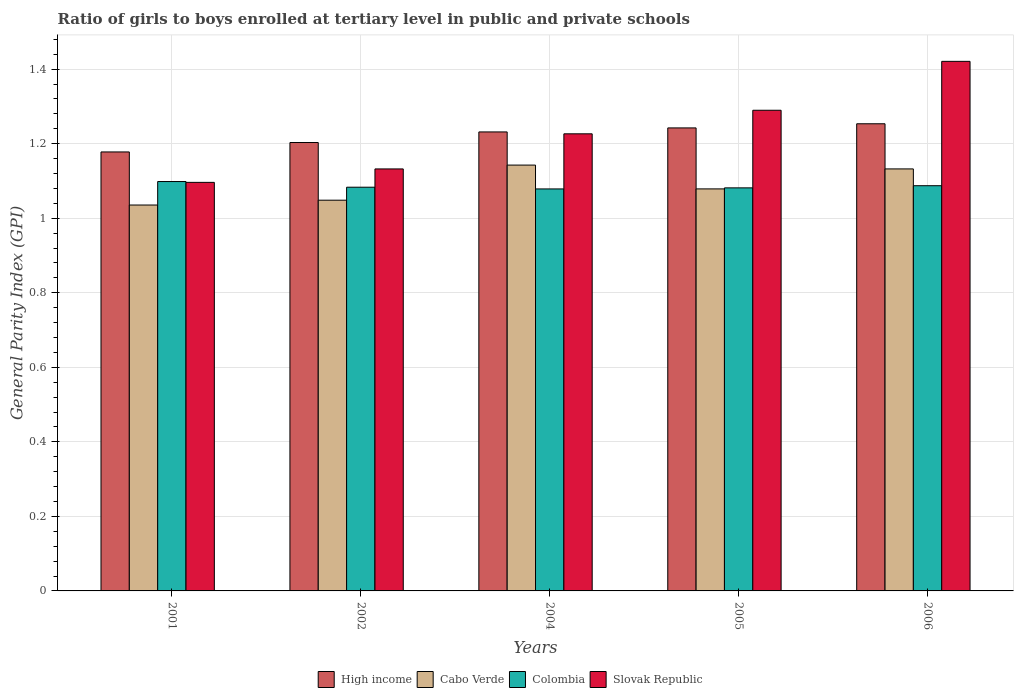How many different coloured bars are there?
Provide a succinct answer. 4. Are the number of bars per tick equal to the number of legend labels?
Keep it short and to the point. Yes. How many bars are there on the 4th tick from the right?
Keep it short and to the point. 4. In how many cases, is the number of bars for a given year not equal to the number of legend labels?
Your response must be concise. 0. What is the general parity index in Slovak Republic in 2002?
Your answer should be compact. 1.13. Across all years, what is the maximum general parity index in Slovak Republic?
Offer a very short reply. 1.42. Across all years, what is the minimum general parity index in Colombia?
Your answer should be compact. 1.08. In which year was the general parity index in Colombia maximum?
Your answer should be compact. 2001. In which year was the general parity index in High income minimum?
Give a very brief answer. 2001. What is the total general parity index in High income in the graph?
Your answer should be compact. 6.11. What is the difference between the general parity index in High income in 2005 and that in 2006?
Your response must be concise. -0.01. What is the difference between the general parity index in Slovak Republic in 2005 and the general parity index in Cabo Verde in 2002?
Your answer should be very brief. 0.24. What is the average general parity index in Cabo Verde per year?
Keep it short and to the point. 1.09. In the year 2001, what is the difference between the general parity index in High income and general parity index in Cabo Verde?
Offer a very short reply. 0.14. What is the ratio of the general parity index in High income in 2001 to that in 2005?
Provide a succinct answer. 0.95. Is the general parity index in Colombia in 2004 less than that in 2006?
Your answer should be very brief. Yes. Is the difference between the general parity index in High income in 2001 and 2005 greater than the difference between the general parity index in Cabo Verde in 2001 and 2005?
Offer a terse response. No. What is the difference between the highest and the second highest general parity index in High income?
Your answer should be compact. 0.01. What is the difference between the highest and the lowest general parity index in Colombia?
Keep it short and to the point. 0.02. Is it the case that in every year, the sum of the general parity index in High income and general parity index in Cabo Verde is greater than the sum of general parity index in Slovak Republic and general parity index in Colombia?
Make the answer very short. Yes. What does the 2nd bar from the left in 2004 represents?
Provide a succinct answer. Cabo Verde. Is it the case that in every year, the sum of the general parity index in Slovak Republic and general parity index in Cabo Verde is greater than the general parity index in High income?
Offer a terse response. Yes. What is the difference between two consecutive major ticks on the Y-axis?
Make the answer very short. 0.2. Does the graph contain grids?
Provide a short and direct response. Yes. How many legend labels are there?
Your response must be concise. 4. What is the title of the graph?
Provide a succinct answer. Ratio of girls to boys enrolled at tertiary level in public and private schools. Does "Seychelles" appear as one of the legend labels in the graph?
Give a very brief answer. No. What is the label or title of the Y-axis?
Ensure brevity in your answer.  General Parity Index (GPI). What is the General Parity Index (GPI) in High income in 2001?
Give a very brief answer. 1.18. What is the General Parity Index (GPI) in Cabo Verde in 2001?
Offer a terse response. 1.04. What is the General Parity Index (GPI) in Colombia in 2001?
Provide a succinct answer. 1.1. What is the General Parity Index (GPI) of Slovak Republic in 2001?
Your answer should be very brief. 1.1. What is the General Parity Index (GPI) in High income in 2002?
Keep it short and to the point. 1.2. What is the General Parity Index (GPI) in Cabo Verde in 2002?
Provide a short and direct response. 1.05. What is the General Parity Index (GPI) of Colombia in 2002?
Provide a succinct answer. 1.08. What is the General Parity Index (GPI) in Slovak Republic in 2002?
Your answer should be very brief. 1.13. What is the General Parity Index (GPI) in High income in 2004?
Offer a terse response. 1.23. What is the General Parity Index (GPI) of Cabo Verde in 2004?
Your response must be concise. 1.14. What is the General Parity Index (GPI) of Colombia in 2004?
Your answer should be very brief. 1.08. What is the General Parity Index (GPI) of Slovak Republic in 2004?
Offer a terse response. 1.23. What is the General Parity Index (GPI) in High income in 2005?
Make the answer very short. 1.24. What is the General Parity Index (GPI) in Cabo Verde in 2005?
Your answer should be very brief. 1.08. What is the General Parity Index (GPI) of Colombia in 2005?
Ensure brevity in your answer.  1.08. What is the General Parity Index (GPI) of Slovak Republic in 2005?
Offer a terse response. 1.29. What is the General Parity Index (GPI) in High income in 2006?
Give a very brief answer. 1.25. What is the General Parity Index (GPI) in Cabo Verde in 2006?
Your answer should be compact. 1.13. What is the General Parity Index (GPI) of Colombia in 2006?
Ensure brevity in your answer.  1.09. What is the General Parity Index (GPI) in Slovak Republic in 2006?
Keep it short and to the point. 1.42. Across all years, what is the maximum General Parity Index (GPI) in High income?
Provide a succinct answer. 1.25. Across all years, what is the maximum General Parity Index (GPI) in Cabo Verde?
Provide a short and direct response. 1.14. Across all years, what is the maximum General Parity Index (GPI) of Colombia?
Ensure brevity in your answer.  1.1. Across all years, what is the maximum General Parity Index (GPI) in Slovak Republic?
Provide a succinct answer. 1.42. Across all years, what is the minimum General Parity Index (GPI) of High income?
Give a very brief answer. 1.18. Across all years, what is the minimum General Parity Index (GPI) in Cabo Verde?
Offer a very short reply. 1.04. Across all years, what is the minimum General Parity Index (GPI) in Colombia?
Offer a terse response. 1.08. Across all years, what is the minimum General Parity Index (GPI) in Slovak Republic?
Keep it short and to the point. 1.1. What is the total General Parity Index (GPI) of High income in the graph?
Your answer should be compact. 6.11. What is the total General Parity Index (GPI) in Cabo Verde in the graph?
Give a very brief answer. 5.44. What is the total General Parity Index (GPI) in Colombia in the graph?
Provide a succinct answer. 5.43. What is the total General Parity Index (GPI) of Slovak Republic in the graph?
Ensure brevity in your answer.  6.16. What is the difference between the General Parity Index (GPI) in High income in 2001 and that in 2002?
Your answer should be very brief. -0.03. What is the difference between the General Parity Index (GPI) of Cabo Verde in 2001 and that in 2002?
Your response must be concise. -0.01. What is the difference between the General Parity Index (GPI) of Colombia in 2001 and that in 2002?
Give a very brief answer. 0.02. What is the difference between the General Parity Index (GPI) in Slovak Republic in 2001 and that in 2002?
Your answer should be very brief. -0.04. What is the difference between the General Parity Index (GPI) of High income in 2001 and that in 2004?
Make the answer very short. -0.05. What is the difference between the General Parity Index (GPI) of Cabo Verde in 2001 and that in 2004?
Provide a short and direct response. -0.11. What is the difference between the General Parity Index (GPI) in Colombia in 2001 and that in 2004?
Ensure brevity in your answer.  0.02. What is the difference between the General Parity Index (GPI) in Slovak Republic in 2001 and that in 2004?
Provide a succinct answer. -0.13. What is the difference between the General Parity Index (GPI) of High income in 2001 and that in 2005?
Offer a very short reply. -0.06. What is the difference between the General Parity Index (GPI) in Cabo Verde in 2001 and that in 2005?
Provide a succinct answer. -0.04. What is the difference between the General Parity Index (GPI) in Colombia in 2001 and that in 2005?
Your response must be concise. 0.02. What is the difference between the General Parity Index (GPI) of Slovak Republic in 2001 and that in 2005?
Provide a short and direct response. -0.19. What is the difference between the General Parity Index (GPI) in High income in 2001 and that in 2006?
Provide a short and direct response. -0.08. What is the difference between the General Parity Index (GPI) of Cabo Verde in 2001 and that in 2006?
Your response must be concise. -0.1. What is the difference between the General Parity Index (GPI) of Colombia in 2001 and that in 2006?
Provide a succinct answer. 0.01. What is the difference between the General Parity Index (GPI) in Slovak Republic in 2001 and that in 2006?
Give a very brief answer. -0.32. What is the difference between the General Parity Index (GPI) in High income in 2002 and that in 2004?
Give a very brief answer. -0.03. What is the difference between the General Parity Index (GPI) in Cabo Verde in 2002 and that in 2004?
Your answer should be very brief. -0.09. What is the difference between the General Parity Index (GPI) of Colombia in 2002 and that in 2004?
Offer a terse response. 0. What is the difference between the General Parity Index (GPI) in Slovak Republic in 2002 and that in 2004?
Provide a short and direct response. -0.09. What is the difference between the General Parity Index (GPI) in High income in 2002 and that in 2005?
Provide a succinct answer. -0.04. What is the difference between the General Parity Index (GPI) in Cabo Verde in 2002 and that in 2005?
Your response must be concise. -0.03. What is the difference between the General Parity Index (GPI) of Colombia in 2002 and that in 2005?
Your response must be concise. 0. What is the difference between the General Parity Index (GPI) in Slovak Republic in 2002 and that in 2005?
Provide a short and direct response. -0.16. What is the difference between the General Parity Index (GPI) of High income in 2002 and that in 2006?
Your answer should be very brief. -0.05. What is the difference between the General Parity Index (GPI) of Cabo Verde in 2002 and that in 2006?
Provide a short and direct response. -0.08. What is the difference between the General Parity Index (GPI) in Colombia in 2002 and that in 2006?
Ensure brevity in your answer.  -0. What is the difference between the General Parity Index (GPI) of Slovak Republic in 2002 and that in 2006?
Provide a succinct answer. -0.29. What is the difference between the General Parity Index (GPI) in High income in 2004 and that in 2005?
Offer a terse response. -0.01. What is the difference between the General Parity Index (GPI) of Cabo Verde in 2004 and that in 2005?
Provide a short and direct response. 0.06. What is the difference between the General Parity Index (GPI) of Colombia in 2004 and that in 2005?
Ensure brevity in your answer.  -0. What is the difference between the General Parity Index (GPI) in Slovak Republic in 2004 and that in 2005?
Offer a very short reply. -0.06. What is the difference between the General Parity Index (GPI) of High income in 2004 and that in 2006?
Your answer should be very brief. -0.02. What is the difference between the General Parity Index (GPI) in Cabo Verde in 2004 and that in 2006?
Your answer should be compact. 0.01. What is the difference between the General Parity Index (GPI) of Colombia in 2004 and that in 2006?
Provide a succinct answer. -0.01. What is the difference between the General Parity Index (GPI) in Slovak Republic in 2004 and that in 2006?
Make the answer very short. -0.19. What is the difference between the General Parity Index (GPI) in High income in 2005 and that in 2006?
Provide a short and direct response. -0.01. What is the difference between the General Parity Index (GPI) in Cabo Verde in 2005 and that in 2006?
Offer a very short reply. -0.05. What is the difference between the General Parity Index (GPI) in Colombia in 2005 and that in 2006?
Ensure brevity in your answer.  -0.01. What is the difference between the General Parity Index (GPI) in Slovak Republic in 2005 and that in 2006?
Provide a short and direct response. -0.13. What is the difference between the General Parity Index (GPI) in High income in 2001 and the General Parity Index (GPI) in Cabo Verde in 2002?
Your answer should be compact. 0.13. What is the difference between the General Parity Index (GPI) in High income in 2001 and the General Parity Index (GPI) in Colombia in 2002?
Give a very brief answer. 0.09. What is the difference between the General Parity Index (GPI) in High income in 2001 and the General Parity Index (GPI) in Slovak Republic in 2002?
Your answer should be compact. 0.05. What is the difference between the General Parity Index (GPI) in Cabo Verde in 2001 and the General Parity Index (GPI) in Colombia in 2002?
Offer a terse response. -0.05. What is the difference between the General Parity Index (GPI) of Cabo Verde in 2001 and the General Parity Index (GPI) of Slovak Republic in 2002?
Your answer should be compact. -0.1. What is the difference between the General Parity Index (GPI) of Colombia in 2001 and the General Parity Index (GPI) of Slovak Republic in 2002?
Provide a short and direct response. -0.03. What is the difference between the General Parity Index (GPI) of High income in 2001 and the General Parity Index (GPI) of Cabo Verde in 2004?
Make the answer very short. 0.04. What is the difference between the General Parity Index (GPI) in High income in 2001 and the General Parity Index (GPI) in Colombia in 2004?
Your answer should be very brief. 0.1. What is the difference between the General Parity Index (GPI) of High income in 2001 and the General Parity Index (GPI) of Slovak Republic in 2004?
Your response must be concise. -0.05. What is the difference between the General Parity Index (GPI) in Cabo Verde in 2001 and the General Parity Index (GPI) in Colombia in 2004?
Make the answer very short. -0.04. What is the difference between the General Parity Index (GPI) of Cabo Verde in 2001 and the General Parity Index (GPI) of Slovak Republic in 2004?
Offer a very short reply. -0.19. What is the difference between the General Parity Index (GPI) in Colombia in 2001 and the General Parity Index (GPI) in Slovak Republic in 2004?
Your answer should be compact. -0.13. What is the difference between the General Parity Index (GPI) in High income in 2001 and the General Parity Index (GPI) in Cabo Verde in 2005?
Provide a short and direct response. 0.1. What is the difference between the General Parity Index (GPI) in High income in 2001 and the General Parity Index (GPI) in Colombia in 2005?
Give a very brief answer. 0.1. What is the difference between the General Parity Index (GPI) in High income in 2001 and the General Parity Index (GPI) in Slovak Republic in 2005?
Your answer should be compact. -0.11. What is the difference between the General Parity Index (GPI) of Cabo Verde in 2001 and the General Parity Index (GPI) of Colombia in 2005?
Offer a very short reply. -0.05. What is the difference between the General Parity Index (GPI) in Cabo Verde in 2001 and the General Parity Index (GPI) in Slovak Republic in 2005?
Keep it short and to the point. -0.25. What is the difference between the General Parity Index (GPI) in Colombia in 2001 and the General Parity Index (GPI) in Slovak Republic in 2005?
Offer a terse response. -0.19. What is the difference between the General Parity Index (GPI) in High income in 2001 and the General Parity Index (GPI) in Cabo Verde in 2006?
Your answer should be compact. 0.05. What is the difference between the General Parity Index (GPI) of High income in 2001 and the General Parity Index (GPI) of Colombia in 2006?
Ensure brevity in your answer.  0.09. What is the difference between the General Parity Index (GPI) in High income in 2001 and the General Parity Index (GPI) in Slovak Republic in 2006?
Your answer should be very brief. -0.24. What is the difference between the General Parity Index (GPI) in Cabo Verde in 2001 and the General Parity Index (GPI) in Colombia in 2006?
Your answer should be compact. -0.05. What is the difference between the General Parity Index (GPI) in Cabo Verde in 2001 and the General Parity Index (GPI) in Slovak Republic in 2006?
Your response must be concise. -0.39. What is the difference between the General Parity Index (GPI) in Colombia in 2001 and the General Parity Index (GPI) in Slovak Republic in 2006?
Keep it short and to the point. -0.32. What is the difference between the General Parity Index (GPI) of High income in 2002 and the General Parity Index (GPI) of Cabo Verde in 2004?
Provide a succinct answer. 0.06. What is the difference between the General Parity Index (GPI) of High income in 2002 and the General Parity Index (GPI) of Colombia in 2004?
Your response must be concise. 0.12. What is the difference between the General Parity Index (GPI) in High income in 2002 and the General Parity Index (GPI) in Slovak Republic in 2004?
Provide a succinct answer. -0.02. What is the difference between the General Parity Index (GPI) of Cabo Verde in 2002 and the General Parity Index (GPI) of Colombia in 2004?
Offer a very short reply. -0.03. What is the difference between the General Parity Index (GPI) of Cabo Verde in 2002 and the General Parity Index (GPI) of Slovak Republic in 2004?
Keep it short and to the point. -0.18. What is the difference between the General Parity Index (GPI) of Colombia in 2002 and the General Parity Index (GPI) of Slovak Republic in 2004?
Keep it short and to the point. -0.14. What is the difference between the General Parity Index (GPI) in High income in 2002 and the General Parity Index (GPI) in Cabo Verde in 2005?
Your answer should be very brief. 0.12. What is the difference between the General Parity Index (GPI) of High income in 2002 and the General Parity Index (GPI) of Colombia in 2005?
Give a very brief answer. 0.12. What is the difference between the General Parity Index (GPI) of High income in 2002 and the General Parity Index (GPI) of Slovak Republic in 2005?
Provide a succinct answer. -0.09. What is the difference between the General Parity Index (GPI) in Cabo Verde in 2002 and the General Parity Index (GPI) in Colombia in 2005?
Provide a succinct answer. -0.03. What is the difference between the General Parity Index (GPI) in Cabo Verde in 2002 and the General Parity Index (GPI) in Slovak Republic in 2005?
Your response must be concise. -0.24. What is the difference between the General Parity Index (GPI) of Colombia in 2002 and the General Parity Index (GPI) of Slovak Republic in 2005?
Your answer should be very brief. -0.21. What is the difference between the General Parity Index (GPI) in High income in 2002 and the General Parity Index (GPI) in Cabo Verde in 2006?
Your answer should be compact. 0.07. What is the difference between the General Parity Index (GPI) in High income in 2002 and the General Parity Index (GPI) in Colombia in 2006?
Give a very brief answer. 0.12. What is the difference between the General Parity Index (GPI) in High income in 2002 and the General Parity Index (GPI) in Slovak Republic in 2006?
Provide a succinct answer. -0.22. What is the difference between the General Parity Index (GPI) in Cabo Verde in 2002 and the General Parity Index (GPI) in Colombia in 2006?
Make the answer very short. -0.04. What is the difference between the General Parity Index (GPI) in Cabo Verde in 2002 and the General Parity Index (GPI) in Slovak Republic in 2006?
Keep it short and to the point. -0.37. What is the difference between the General Parity Index (GPI) of Colombia in 2002 and the General Parity Index (GPI) of Slovak Republic in 2006?
Give a very brief answer. -0.34. What is the difference between the General Parity Index (GPI) of High income in 2004 and the General Parity Index (GPI) of Cabo Verde in 2005?
Ensure brevity in your answer.  0.15. What is the difference between the General Parity Index (GPI) of High income in 2004 and the General Parity Index (GPI) of Colombia in 2005?
Give a very brief answer. 0.15. What is the difference between the General Parity Index (GPI) in High income in 2004 and the General Parity Index (GPI) in Slovak Republic in 2005?
Make the answer very short. -0.06. What is the difference between the General Parity Index (GPI) in Cabo Verde in 2004 and the General Parity Index (GPI) in Colombia in 2005?
Ensure brevity in your answer.  0.06. What is the difference between the General Parity Index (GPI) of Cabo Verde in 2004 and the General Parity Index (GPI) of Slovak Republic in 2005?
Ensure brevity in your answer.  -0.15. What is the difference between the General Parity Index (GPI) in Colombia in 2004 and the General Parity Index (GPI) in Slovak Republic in 2005?
Give a very brief answer. -0.21. What is the difference between the General Parity Index (GPI) of High income in 2004 and the General Parity Index (GPI) of Cabo Verde in 2006?
Your answer should be very brief. 0.1. What is the difference between the General Parity Index (GPI) in High income in 2004 and the General Parity Index (GPI) in Colombia in 2006?
Offer a terse response. 0.14. What is the difference between the General Parity Index (GPI) in High income in 2004 and the General Parity Index (GPI) in Slovak Republic in 2006?
Keep it short and to the point. -0.19. What is the difference between the General Parity Index (GPI) of Cabo Verde in 2004 and the General Parity Index (GPI) of Colombia in 2006?
Provide a short and direct response. 0.06. What is the difference between the General Parity Index (GPI) in Cabo Verde in 2004 and the General Parity Index (GPI) in Slovak Republic in 2006?
Your response must be concise. -0.28. What is the difference between the General Parity Index (GPI) in Colombia in 2004 and the General Parity Index (GPI) in Slovak Republic in 2006?
Your answer should be compact. -0.34. What is the difference between the General Parity Index (GPI) in High income in 2005 and the General Parity Index (GPI) in Cabo Verde in 2006?
Your response must be concise. 0.11. What is the difference between the General Parity Index (GPI) of High income in 2005 and the General Parity Index (GPI) of Colombia in 2006?
Your response must be concise. 0.16. What is the difference between the General Parity Index (GPI) in High income in 2005 and the General Parity Index (GPI) in Slovak Republic in 2006?
Your response must be concise. -0.18. What is the difference between the General Parity Index (GPI) of Cabo Verde in 2005 and the General Parity Index (GPI) of Colombia in 2006?
Keep it short and to the point. -0.01. What is the difference between the General Parity Index (GPI) in Cabo Verde in 2005 and the General Parity Index (GPI) in Slovak Republic in 2006?
Your response must be concise. -0.34. What is the difference between the General Parity Index (GPI) in Colombia in 2005 and the General Parity Index (GPI) in Slovak Republic in 2006?
Ensure brevity in your answer.  -0.34. What is the average General Parity Index (GPI) of High income per year?
Provide a succinct answer. 1.22. What is the average General Parity Index (GPI) in Cabo Verde per year?
Provide a succinct answer. 1.09. What is the average General Parity Index (GPI) of Colombia per year?
Your answer should be very brief. 1.09. What is the average General Parity Index (GPI) of Slovak Republic per year?
Provide a short and direct response. 1.23. In the year 2001, what is the difference between the General Parity Index (GPI) in High income and General Parity Index (GPI) in Cabo Verde?
Offer a terse response. 0.14. In the year 2001, what is the difference between the General Parity Index (GPI) of High income and General Parity Index (GPI) of Colombia?
Your answer should be very brief. 0.08. In the year 2001, what is the difference between the General Parity Index (GPI) in High income and General Parity Index (GPI) in Slovak Republic?
Offer a very short reply. 0.08. In the year 2001, what is the difference between the General Parity Index (GPI) in Cabo Verde and General Parity Index (GPI) in Colombia?
Make the answer very short. -0.06. In the year 2001, what is the difference between the General Parity Index (GPI) of Cabo Verde and General Parity Index (GPI) of Slovak Republic?
Your answer should be compact. -0.06. In the year 2001, what is the difference between the General Parity Index (GPI) of Colombia and General Parity Index (GPI) of Slovak Republic?
Offer a terse response. 0. In the year 2002, what is the difference between the General Parity Index (GPI) of High income and General Parity Index (GPI) of Cabo Verde?
Ensure brevity in your answer.  0.15. In the year 2002, what is the difference between the General Parity Index (GPI) of High income and General Parity Index (GPI) of Colombia?
Keep it short and to the point. 0.12. In the year 2002, what is the difference between the General Parity Index (GPI) of High income and General Parity Index (GPI) of Slovak Republic?
Keep it short and to the point. 0.07. In the year 2002, what is the difference between the General Parity Index (GPI) in Cabo Verde and General Parity Index (GPI) in Colombia?
Your response must be concise. -0.03. In the year 2002, what is the difference between the General Parity Index (GPI) of Cabo Verde and General Parity Index (GPI) of Slovak Republic?
Ensure brevity in your answer.  -0.08. In the year 2002, what is the difference between the General Parity Index (GPI) of Colombia and General Parity Index (GPI) of Slovak Republic?
Provide a succinct answer. -0.05. In the year 2004, what is the difference between the General Parity Index (GPI) in High income and General Parity Index (GPI) in Cabo Verde?
Give a very brief answer. 0.09. In the year 2004, what is the difference between the General Parity Index (GPI) in High income and General Parity Index (GPI) in Colombia?
Offer a very short reply. 0.15. In the year 2004, what is the difference between the General Parity Index (GPI) of High income and General Parity Index (GPI) of Slovak Republic?
Give a very brief answer. 0.01. In the year 2004, what is the difference between the General Parity Index (GPI) in Cabo Verde and General Parity Index (GPI) in Colombia?
Ensure brevity in your answer.  0.06. In the year 2004, what is the difference between the General Parity Index (GPI) in Cabo Verde and General Parity Index (GPI) in Slovak Republic?
Provide a succinct answer. -0.08. In the year 2004, what is the difference between the General Parity Index (GPI) of Colombia and General Parity Index (GPI) of Slovak Republic?
Your answer should be compact. -0.15. In the year 2005, what is the difference between the General Parity Index (GPI) of High income and General Parity Index (GPI) of Cabo Verde?
Your answer should be very brief. 0.16. In the year 2005, what is the difference between the General Parity Index (GPI) in High income and General Parity Index (GPI) in Colombia?
Give a very brief answer. 0.16. In the year 2005, what is the difference between the General Parity Index (GPI) in High income and General Parity Index (GPI) in Slovak Republic?
Provide a succinct answer. -0.05. In the year 2005, what is the difference between the General Parity Index (GPI) of Cabo Verde and General Parity Index (GPI) of Colombia?
Your answer should be very brief. -0. In the year 2005, what is the difference between the General Parity Index (GPI) in Cabo Verde and General Parity Index (GPI) in Slovak Republic?
Make the answer very short. -0.21. In the year 2005, what is the difference between the General Parity Index (GPI) in Colombia and General Parity Index (GPI) in Slovak Republic?
Make the answer very short. -0.21. In the year 2006, what is the difference between the General Parity Index (GPI) of High income and General Parity Index (GPI) of Cabo Verde?
Make the answer very short. 0.12. In the year 2006, what is the difference between the General Parity Index (GPI) of High income and General Parity Index (GPI) of Colombia?
Provide a short and direct response. 0.17. In the year 2006, what is the difference between the General Parity Index (GPI) in High income and General Parity Index (GPI) in Slovak Republic?
Ensure brevity in your answer.  -0.17. In the year 2006, what is the difference between the General Parity Index (GPI) of Cabo Verde and General Parity Index (GPI) of Colombia?
Keep it short and to the point. 0.05. In the year 2006, what is the difference between the General Parity Index (GPI) in Cabo Verde and General Parity Index (GPI) in Slovak Republic?
Your response must be concise. -0.29. In the year 2006, what is the difference between the General Parity Index (GPI) in Colombia and General Parity Index (GPI) in Slovak Republic?
Your response must be concise. -0.33. What is the ratio of the General Parity Index (GPI) of Cabo Verde in 2001 to that in 2002?
Make the answer very short. 0.99. What is the ratio of the General Parity Index (GPI) of Colombia in 2001 to that in 2002?
Your answer should be compact. 1.01. What is the ratio of the General Parity Index (GPI) in Slovak Republic in 2001 to that in 2002?
Make the answer very short. 0.97. What is the ratio of the General Parity Index (GPI) in High income in 2001 to that in 2004?
Provide a short and direct response. 0.96. What is the ratio of the General Parity Index (GPI) in Cabo Verde in 2001 to that in 2004?
Offer a terse response. 0.91. What is the ratio of the General Parity Index (GPI) in Colombia in 2001 to that in 2004?
Provide a succinct answer. 1.02. What is the ratio of the General Parity Index (GPI) in Slovak Republic in 2001 to that in 2004?
Offer a terse response. 0.89. What is the ratio of the General Parity Index (GPI) of High income in 2001 to that in 2005?
Make the answer very short. 0.95. What is the ratio of the General Parity Index (GPI) in Cabo Verde in 2001 to that in 2005?
Ensure brevity in your answer.  0.96. What is the ratio of the General Parity Index (GPI) in Colombia in 2001 to that in 2005?
Offer a very short reply. 1.02. What is the ratio of the General Parity Index (GPI) in High income in 2001 to that in 2006?
Give a very brief answer. 0.94. What is the ratio of the General Parity Index (GPI) in Cabo Verde in 2001 to that in 2006?
Keep it short and to the point. 0.91. What is the ratio of the General Parity Index (GPI) of Colombia in 2001 to that in 2006?
Your answer should be compact. 1.01. What is the ratio of the General Parity Index (GPI) of Slovak Republic in 2001 to that in 2006?
Provide a short and direct response. 0.77. What is the ratio of the General Parity Index (GPI) in High income in 2002 to that in 2004?
Provide a succinct answer. 0.98. What is the ratio of the General Parity Index (GPI) of Cabo Verde in 2002 to that in 2004?
Your answer should be compact. 0.92. What is the ratio of the General Parity Index (GPI) in Slovak Republic in 2002 to that in 2004?
Offer a terse response. 0.92. What is the ratio of the General Parity Index (GPI) in High income in 2002 to that in 2005?
Offer a terse response. 0.97. What is the ratio of the General Parity Index (GPI) of Cabo Verde in 2002 to that in 2005?
Make the answer very short. 0.97. What is the ratio of the General Parity Index (GPI) of Slovak Republic in 2002 to that in 2005?
Your answer should be very brief. 0.88. What is the ratio of the General Parity Index (GPI) in High income in 2002 to that in 2006?
Provide a short and direct response. 0.96. What is the ratio of the General Parity Index (GPI) in Cabo Verde in 2002 to that in 2006?
Your answer should be compact. 0.93. What is the ratio of the General Parity Index (GPI) of Colombia in 2002 to that in 2006?
Your response must be concise. 1. What is the ratio of the General Parity Index (GPI) of Slovak Republic in 2002 to that in 2006?
Give a very brief answer. 0.8. What is the ratio of the General Parity Index (GPI) of Cabo Verde in 2004 to that in 2005?
Offer a very short reply. 1.06. What is the ratio of the General Parity Index (GPI) of Slovak Republic in 2004 to that in 2005?
Provide a short and direct response. 0.95. What is the ratio of the General Parity Index (GPI) in High income in 2004 to that in 2006?
Provide a short and direct response. 0.98. What is the ratio of the General Parity Index (GPI) in Cabo Verde in 2004 to that in 2006?
Offer a very short reply. 1.01. What is the ratio of the General Parity Index (GPI) in Colombia in 2004 to that in 2006?
Provide a succinct answer. 0.99. What is the ratio of the General Parity Index (GPI) in Slovak Republic in 2004 to that in 2006?
Your answer should be compact. 0.86. What is the ratio of the General Parity Index (GPI) in High income in 2005 to that in 2006?
Give a very brief answer. 0.99. What is the ratio of the General Parity Index (GPI) of Cabo Verde in 2005 to that in 2006?
Ensure brevity in your answer.  0.95. What is the ratio of the General Parity Index (GPI) of Colombia in 2005 to that in 2006?
Make the answer very short. 0.99. What is the ratio of the General Parity Index (GPI) in Slovak Republic in 2005 to that in 2006?
Your answer should be compact. 0.91. What is the difference between the highest and the second highest General Parity Index (GPI) of High income?
Your answer should be compact. 0.01. What is the difference between the highest and the second highest General Parity Index (GPI) in Cabo Verde?
Your response must be concise. 0.01. What is the difference between the highest and the second highest General Parity Index (GPI) in Colombia?
Offer a very short reply. 0.01. What is the difference between the highest and the second highest General Parity Index (GPI) in Slovak Republic?
Provide a succinct answer. 0.13. What is the difference between the highest and the lowest General Parity Index (GPI) in High income?
Provide a succinct answer. 0.08. What is the difference between the highest and the lowest General Parity Index (GPI) of Cabo Verde?
Provide a short and direct response. 0.11. What is the difference between the highest and the lowest General Parity Index (GPI) in Colombia?
Your answer should be very brief. 0.02. What is the difference between the highest and the lowest General Parity Index (GPI) in Slovak Republic?
Give a very brief answer. 0.32. 